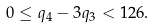<formula> <loc_0><loc_0><loc_500><loc_500>0 \leq q _ { 4 } - 3 q _ { 3 } < 1 2 6 .</formula> 